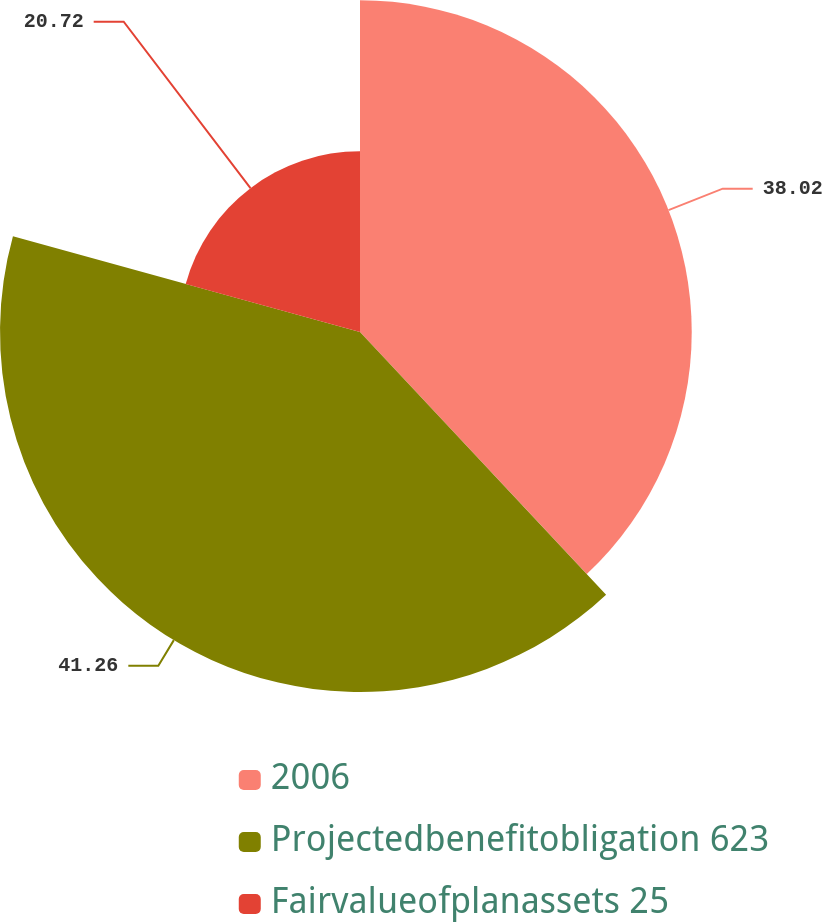Convert chart to OTSL. <chart><loc_0><loc_0><loc_500><loc_500><pie_chart><fcel>2006<fcel>Projectedbenefitobligation 623<fcel>Fairvalueofplanassets 25<nl><fcel>38.02%<fcel>41.26%<fcel>20.72%<nl></chart> 